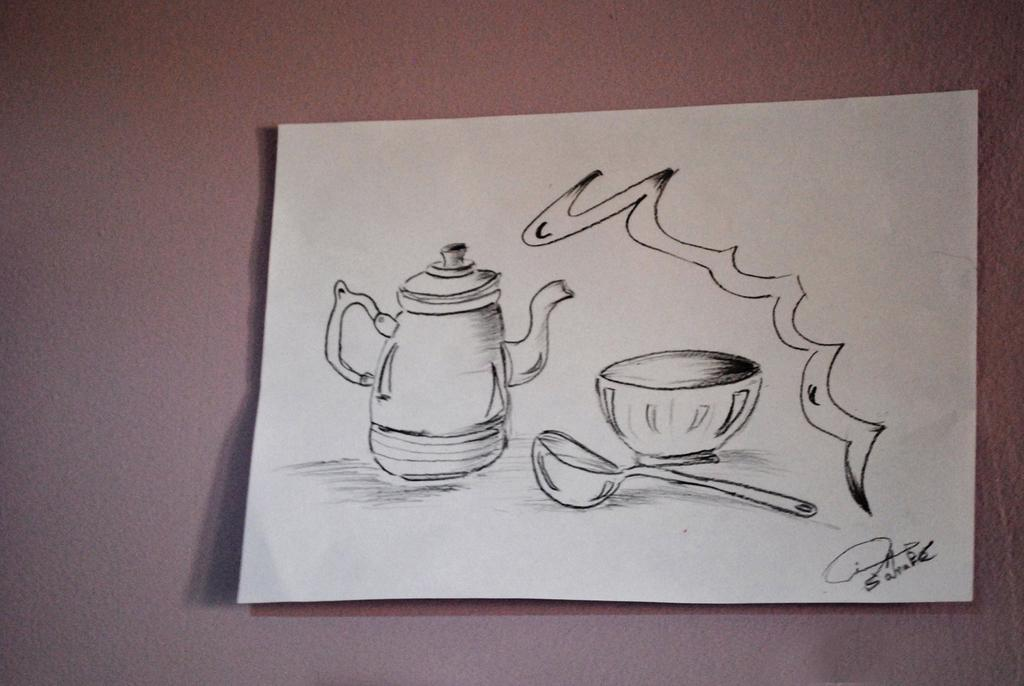What is on the floor in the image? There is a paper on the floor. What is depicted on the paper? There is a painting on the paper. What kitchen appliance can be seen in the image? There is a kettle in the image. What type of dishware is present in the image? There is a bowl in the image. What utensil is visible in the image? There is a spoon in the image. Where can text be found in the image? There is text on the bottom right corner of the paper. What type of toothpaste is being used to paint the volleyball in the image? There is no toothpaste or volleyball present in the image. The painting on the paper does not depict a volleyball. 